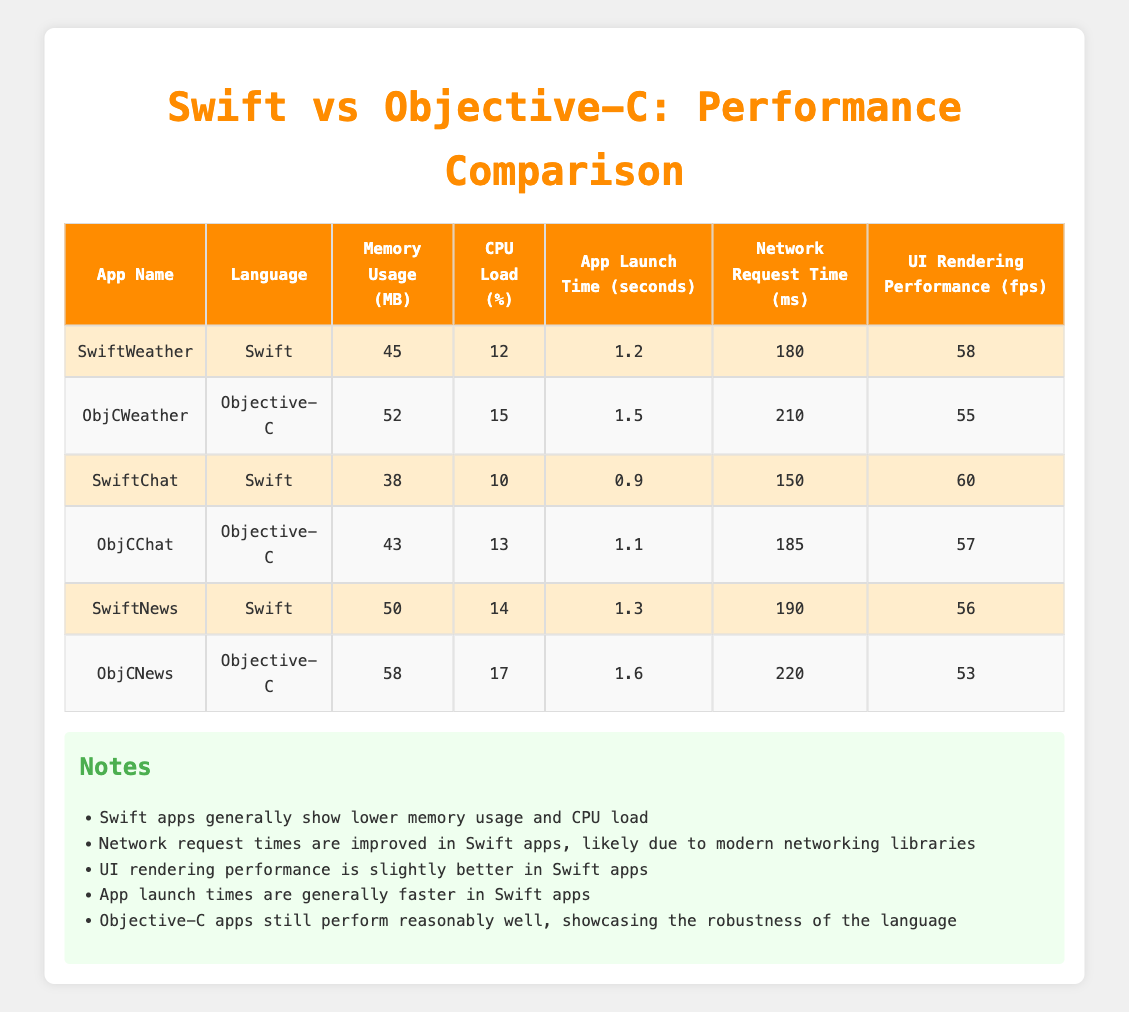What is the memory usage of SwiftWeather? The table shows that SwiftWeather has a memory usage of 45 MB.
Answer: 45 MB Which app has the lowest CPU load? SwiftChat has the lowest CPU load at 10%.
Answer: 10% What is the average app launch time for Objective-C apps? The app launch times for Objective-C apps are 1.5, 1.1, and 1.6 seconds. The total is (1.5 + 1.1 + 1.6) = 4.2 seconds, so the average is 4.2 seconds / 3 = 1.4 seconds.
Answer: 1.4 seconds Is the network request time for SwiftChat less than that of ObjCChat? The network request time for SwiftChat is 150 ms, which is indeed less than ObjCChat's 185 ms.
Answer: Yes Which app has the highest UI rendering performance, and what is its value? Comparing the UI rendering performance values, SwiftChat has the highest at 60 fps.
Answer: SwiftChat: 60 fps What is the difference in memory usage between SwiftNews and ObjCNews? SwiftNews uses 50 MB while ObjCNews uses 58 MB, so the difference is 58 - 50 = 8 MB.
Answer: 8 MB How often does Swift outperform Objective-C in UI rendering performance based on the table? Swift apps outperformed Objective-C apps in UI rendering performance in all instances: 58 fps vs 55 fps, 60 fps vs 57 fps, and 56 fps vs 53 fps.
Answer: Always What is the average network request time for Swift apps? The network request times for Swift apps are 180, 150, and 190 ms. The total is (180 + 150 + 190) = 520 ms, so the average is 520 ms / 3 ≈ 173.33 ms.
Answer: Approximately 173.33 ms Does the data suggest that Objective-C apps have faster app launch times than Swift apps? The app launch times for Objective-C are consistently higher than those for Swift (1.5 vs 1.2, 1.1 vs 0.9, 1.6 vs 1.3).
Answer: No 